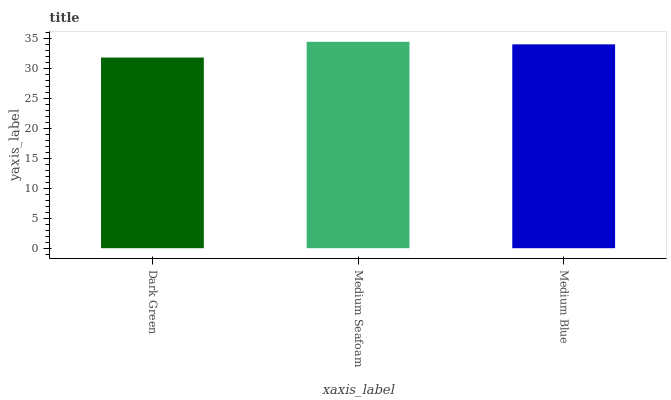Is Medium Blue the minimum?
Answer yes or no. No. Is Medium Blue the maximum?
Answer yes or no. No. Is Medium Seafoam greater than Medium Blue?
Answer yes or no. Yes. Is Medium Blue less than Medium Seafoam?
Answer yes or no. Yes. Is Medium Blue greater than Medium Seafoam?
Answer yes or no. No. Is Medium Seafoam less than Medium Blue?
Answer yes or no. No. Is Medium Blue the high median?
Answer yes or no. Yes. Is Medium Blue the low median?
Answer yes or no. Yes. Is Dark Green the high median?
Answer yes or no. No. Is Medium Seafoam the low median?
Answer yes or no. No. 